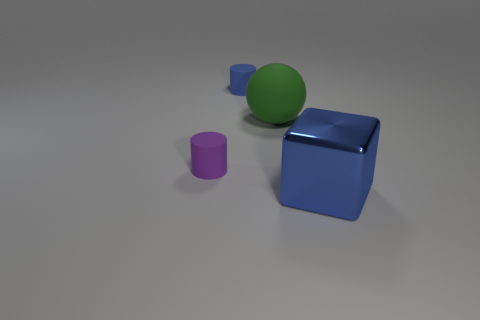There is a thing that is right of the purple rubber thing and in front of the green thing; what material is it?
Make the answer very short. Metal. What is the size of the blue matte cylinder?
Make the answer very short. Small. There is a large metallic block; is it the same color as the rubber thing behind the big green rubber object?
Keep it short and to the point. Yes. What number of other objects are there of the same color as the sphere?
Your response must be concise. 0. Does the cylinder right of the tiny purple thing have the same size as the thing in front of the purple rubber object?
Offer a very short reply. No. The cylinder behind the matte ball is what color?
Make the answer very short. Blue. Are there fewer purple matte cylinders that are in front of the purple matte cylinder than brown shiny spheres?
Provide a succinct answer. No. Does the purple cylinder have the same material as the green ball?
Your response must be concise. Yes. How many things are either blue objects to the left of the metallic thing or big blue blocks on the right side of the tiny purple matte cylinder?
Offer a terse response. 2. Are there fewer large green matte objects than yellow balls?
Provide a succinct answer. No. 